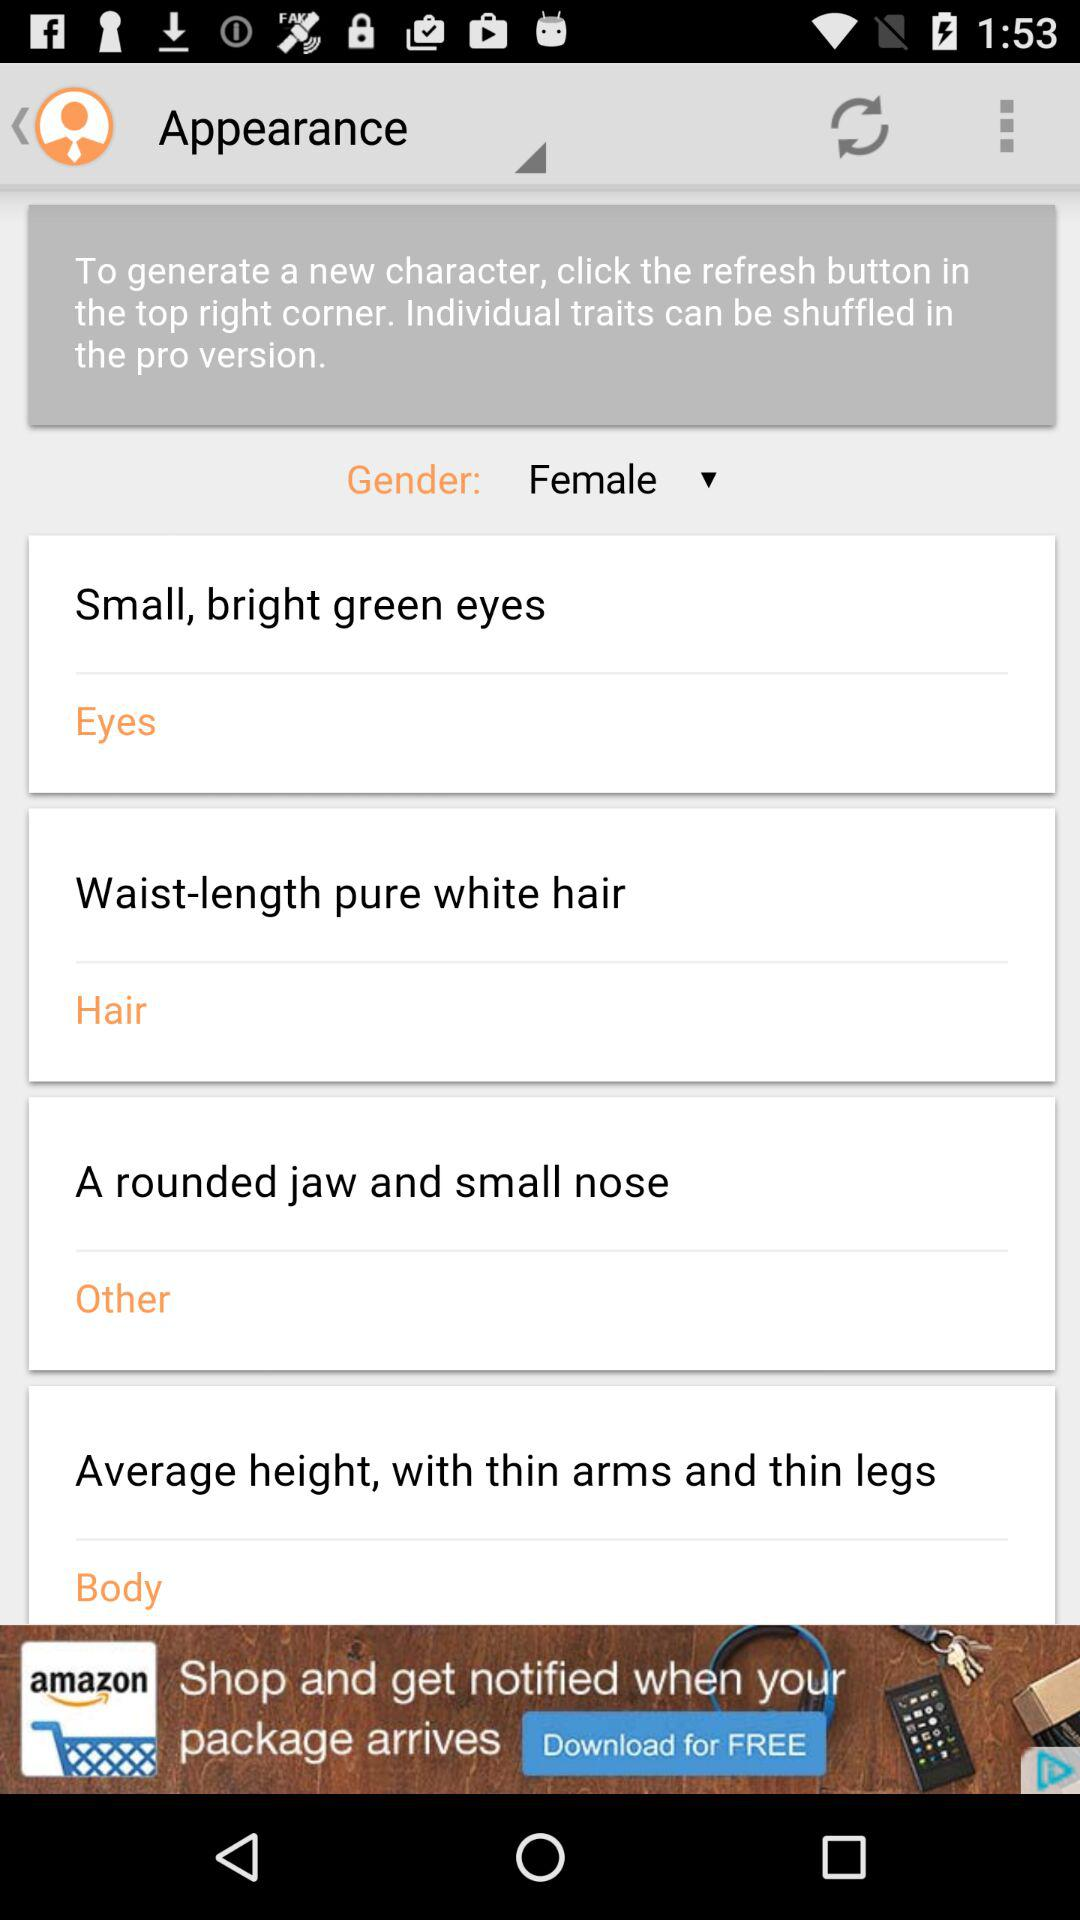What is the mentioned color of the eyes? The mentioned color of the eyes is bright green. 